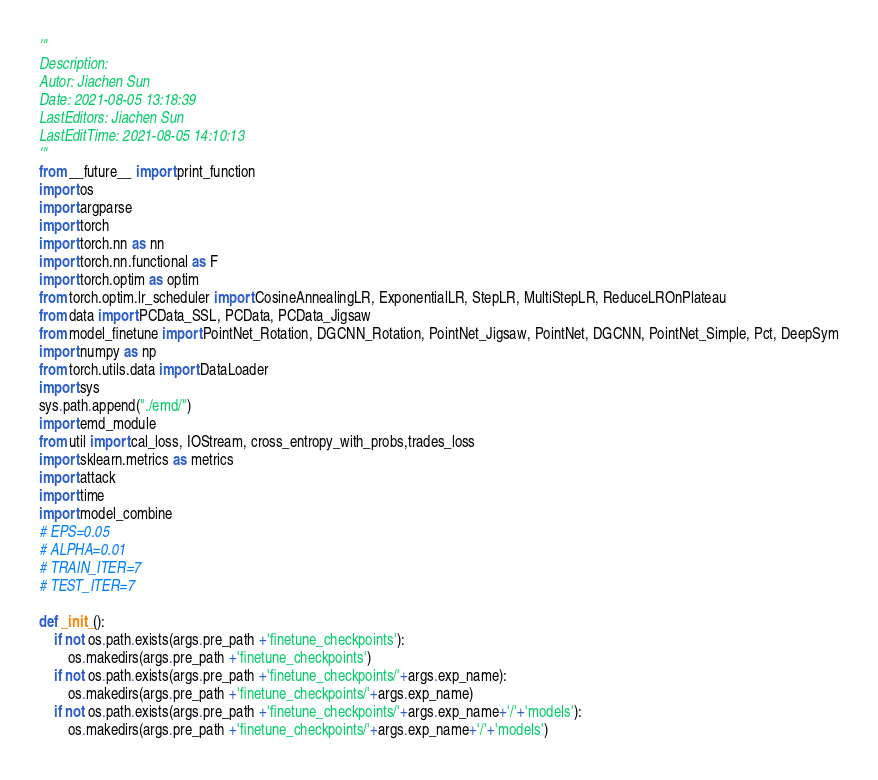<code> <loc_0><loc_0><loc_500><loc_500><_Python_>'''
Description: 
Autor: Jiachen Sun
Date: 2021-08-05 13:18:39
LastEditors: Jiachen Sun
LastEditTime: 2021-08-05 14:10:13
'''
from __future__ import print_function
import os
import argparse
import torch
import torch.nn as nn
import torch.nn.functional as F
import torch.optim as optim
from torch.optim.lr_scheduler import CosineAnnealingLR, ExponentialLR, StepLR, MultiStepLR, ReduceLROnPlateau
from data import PCData_SSL, PCData, PCData_Jigsaw
from model_finetune import PointNet_Rotation, DGCNN_Rotation, PointNet_Jigsaw, PointNet, DGCNN, PointNet_Simple, Pct, DeepSym
import numpy as np
from torch.utils.data import DataLoader
import sys
sys.path.append("./emd/")
import emd_module
from util import cal_loss, IOStream, cross_entropy_with_probs,trades_loss
import sklearn.metrics as metrics
import attack
import time
import model_combine
# EPS=0.05
# ALPHA=0.01
# TRAIN_ITER=7
# TEST_ITER=7

def _init_():
    if not os.path.exists(args.pre_path +'finetune_checkpoints'):
        os.makedirs(args.pre_path +'finetune_checkpoints')
    if not os.path.exists(args.pre_path +'finetune_checkpoints/'+args.exp_name):
        os.makedirs(args.pre_path +'finetune_checkpoints/'+args.exp_name)
    if not os.path.exists(args.pre_path +'finetune_checkpoints/'+args.exp_name+'/'+'models'):
        os.makedirs(args.pre_path +'finetune_checkpoints/'+args.exp_name+'/'+'models')</code> 